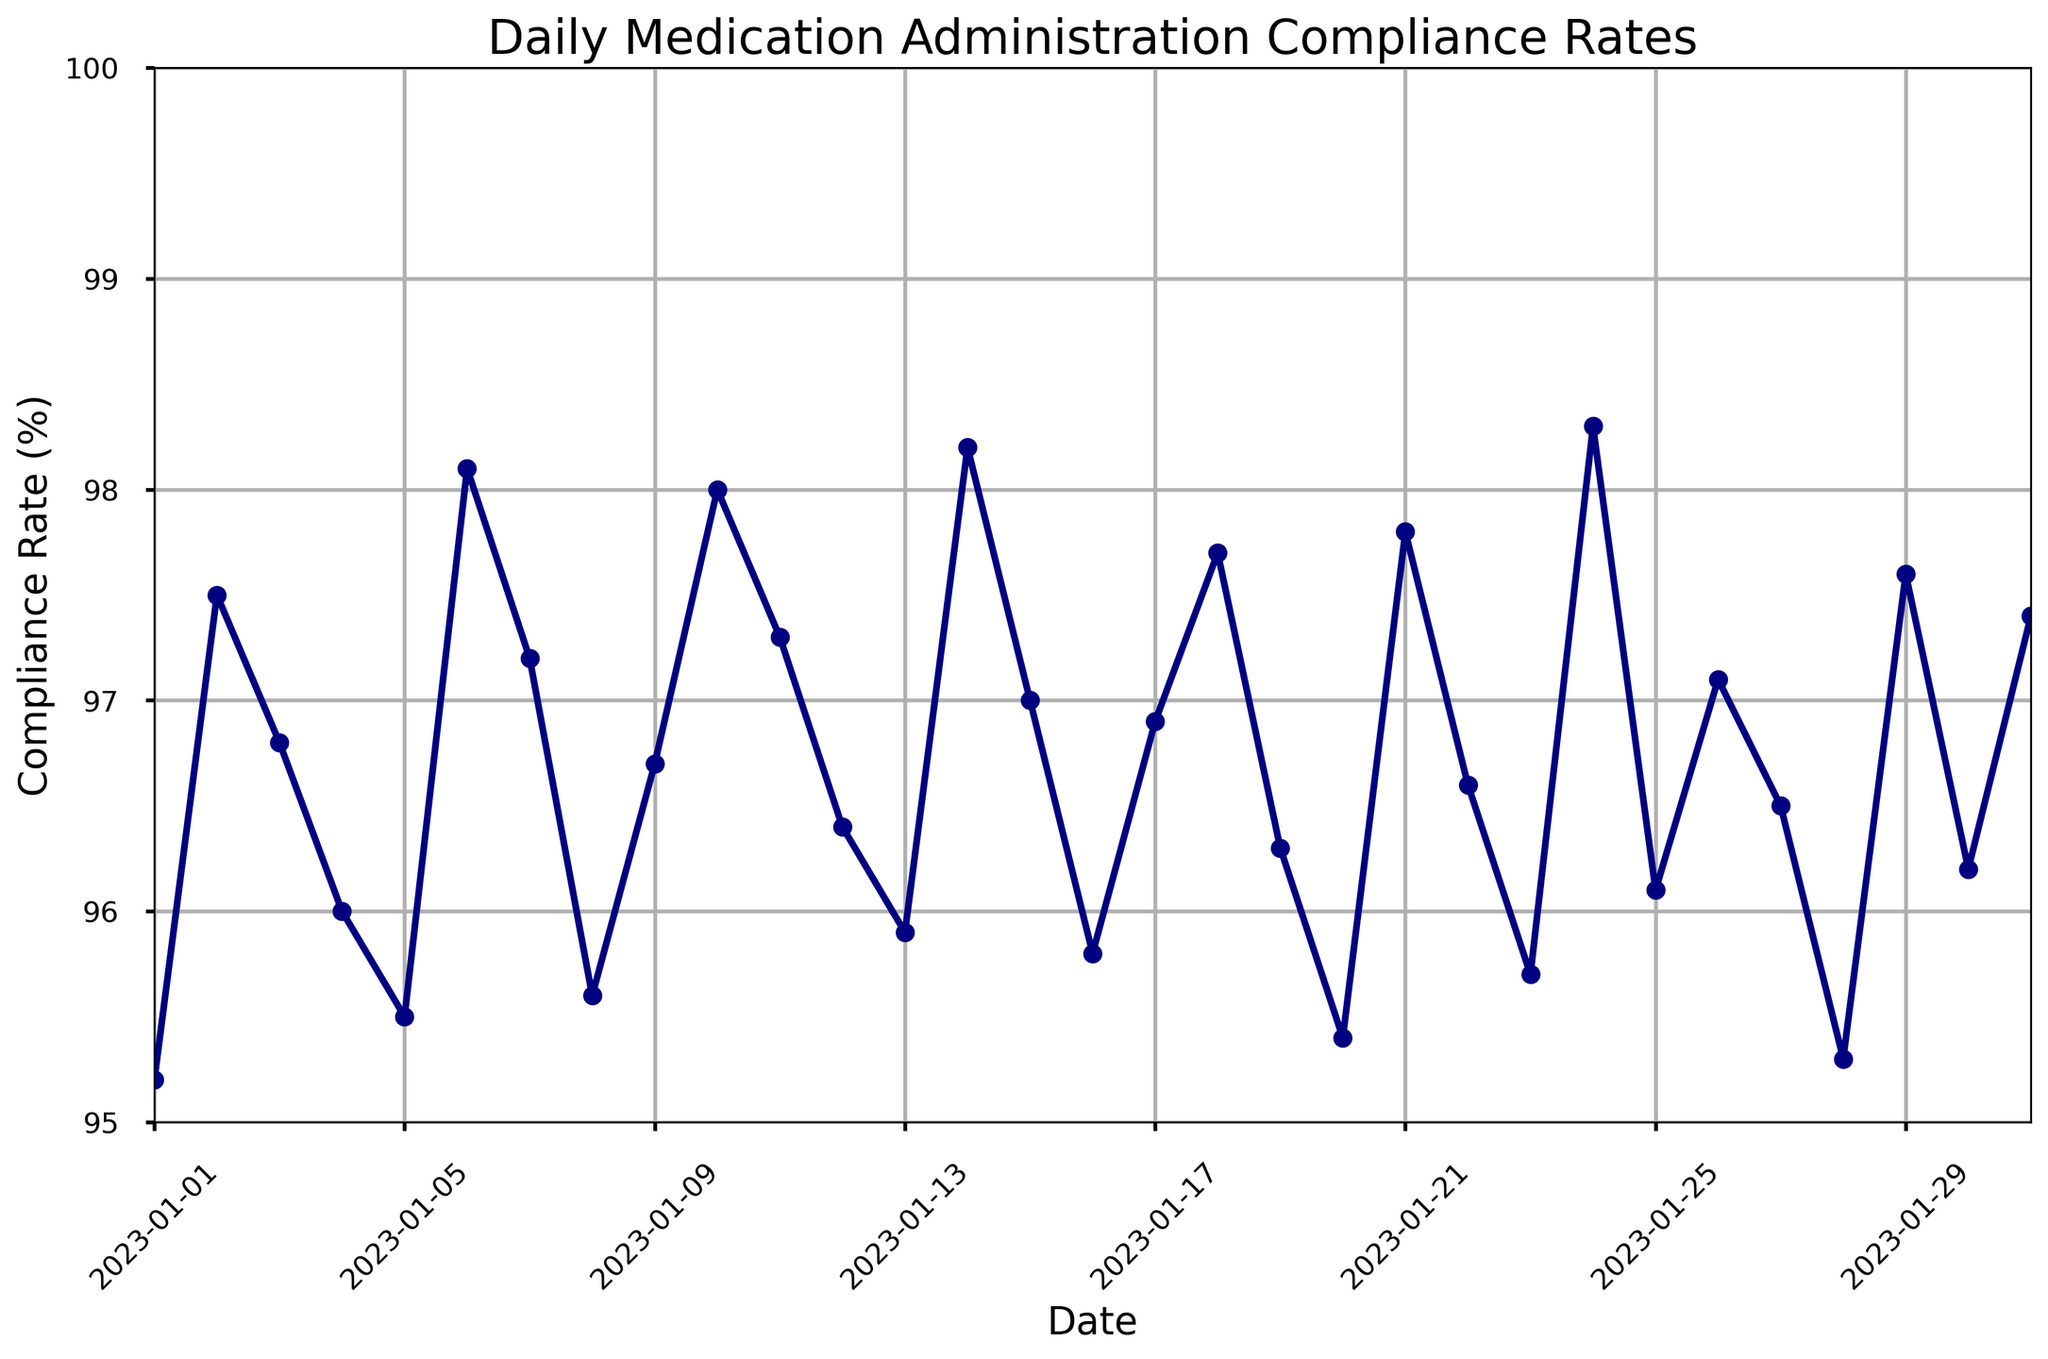What is the compliance rate on January 6th, 2023? Find January 6th on the x-axis and look at the y-value for that date. The y-value shows the compliance rate.
Answer: 98.1% Which two days had the highest compliance rates? Find and compare the highest points on the line plot. The highest points correspond to the dates with the highest y-values.
Answer: January 24th (98.3%) and January 14th (98.2%) What was the average compliance rate for the first week of January 2023? (January 1 to January 7) Sum the compliance rates from January 1 to January 7, and then divide by the number of days. (95.2 + 97.5 + 96.8 + 96.0 + 95.5 + 98.1 + 97.2) / 7
Answer: 96.6% Is the compliance rate higher on January 10th than on January 25th? Compare the y-values for January 10th (98.0%) and January 25th (96.1%).
Answer: Yes What is the difference in compliance rates between the highest and lowest days in January 2023? Identify the highest (98.3% on January 24th) and lowest (95.2% on January 1st) rates and subtract the lower from the higher. (98.3% - 95.2%)
Answer: 3.1% On which dates did the compliance rate first drop below 96% and then rise above 98% afterward? Look for the first case where the line falls below 96% and then find the subsequent point where it rises above 98%.
Answer: Dropped below 96% on January 5th (95.5%) and rose above 98% on January 24th (98.3%) What is the overall trend in compliance rates from January 1st to January 31st? Observe the general direction of the line plot from the start to the end of the month.
Answer: Fluctuations without a clear trend Which day had a compliance rate equal to 97.8%? Find the y-value of 97.8% and trace it back to the corresponding date on the x-axis.
Answer: January 21st Did the compliance rate ever stay constant for two consecutive days? Check for any two consecutive points on the line plot that have the same y-value.
Answer: No 